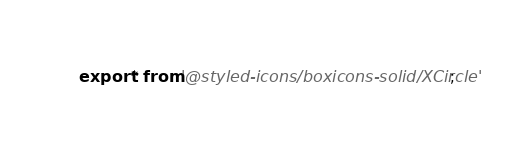<code> <loc_0><loc_0><loc_500><loc_500><_JavaScript_>export * from '@styled-icons/boxicons-solid/XCircle';
</code> 